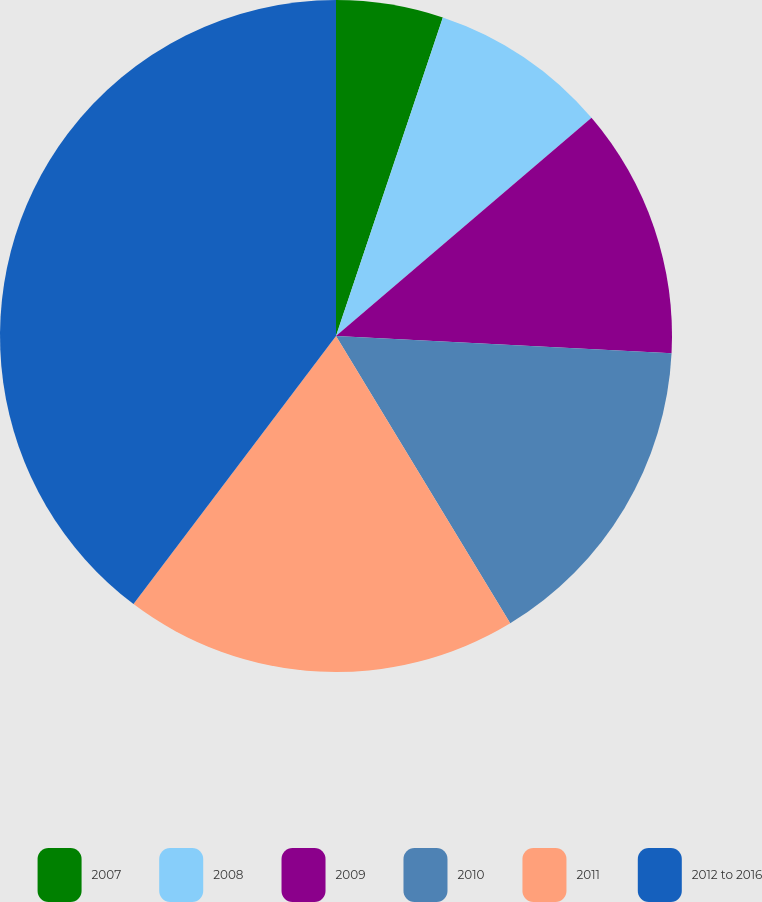<chart> <loc_0><loc_0><loc_500><loc_500><pie_chart><fcel>2007<fcel>2008<fcel>2009<fcel>2010<fcel>2011<fcel>2012 to 2016<nl><fcel>5.15%<fcel>8.6%<fcel>12.06%<fcel>15.51%<fcel>18.97%<fcel>39.7%<nl></chart> 